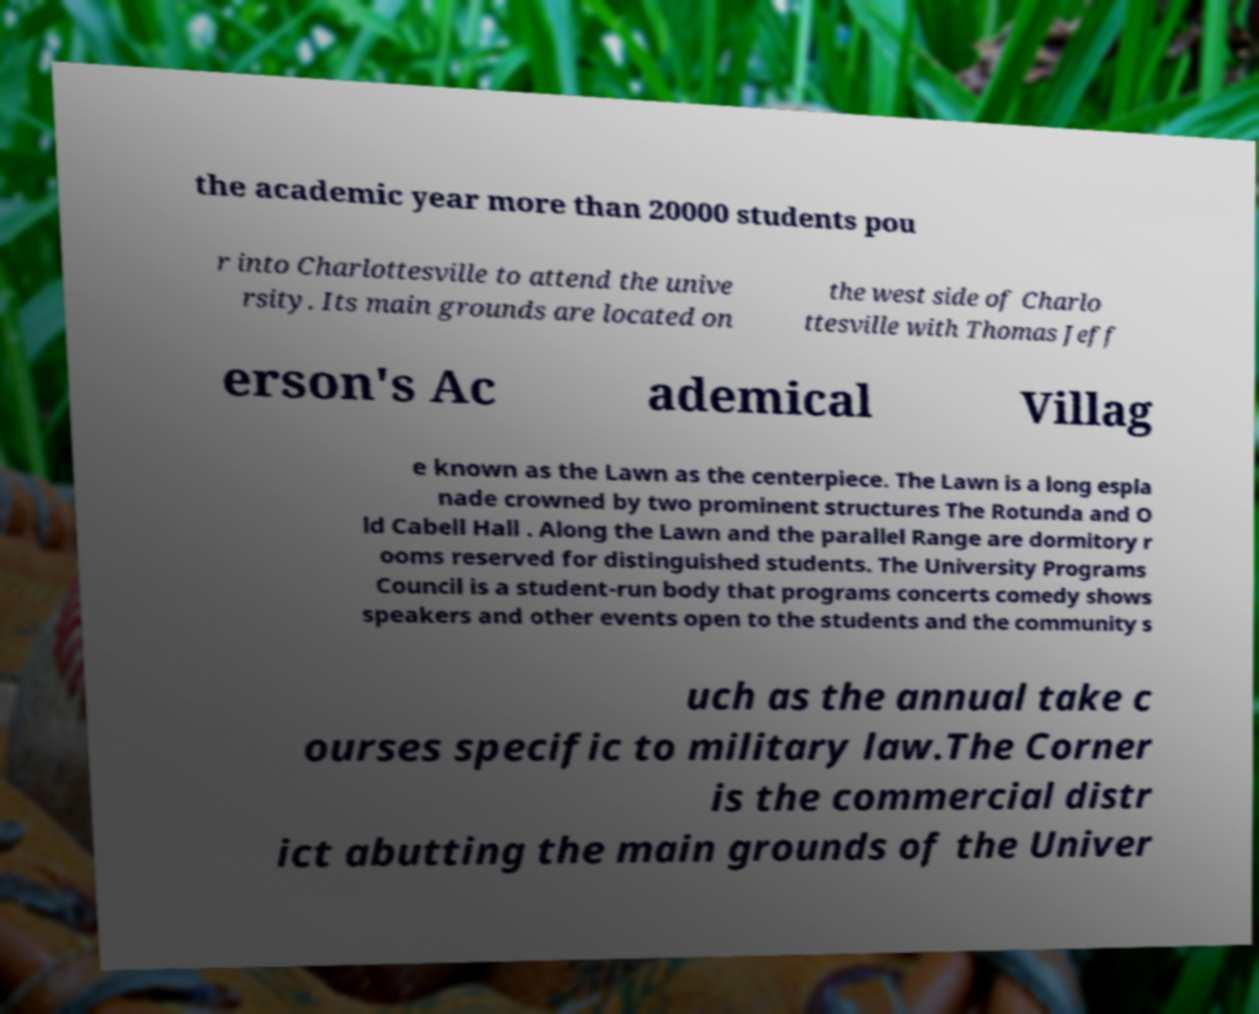Can you accurately transcribe the text from the provided image for me? the academic year more than 20000 students pou r into Charlottesville to attend the unive rsity. Its main grounds are located on the west side of Charlo ttesville with Thomas Jeff erson's Ac ademical Villag e known as the Lawn as the centerpiece. The Lawn is a long espla nade crowned by two prominent structures The Rotunda and O ld Cabell Hall . Along the Lawn and the parallel Range are dormitory r ooms reserved for distinguished students. The University Programs Council is a student-run body that programs concerts comedy shows speakers and other events open to the students and the community s uch as the annual take c ourses specific to military law.The Corner is the commercial distr ict abutting the main grounds of the Univer 